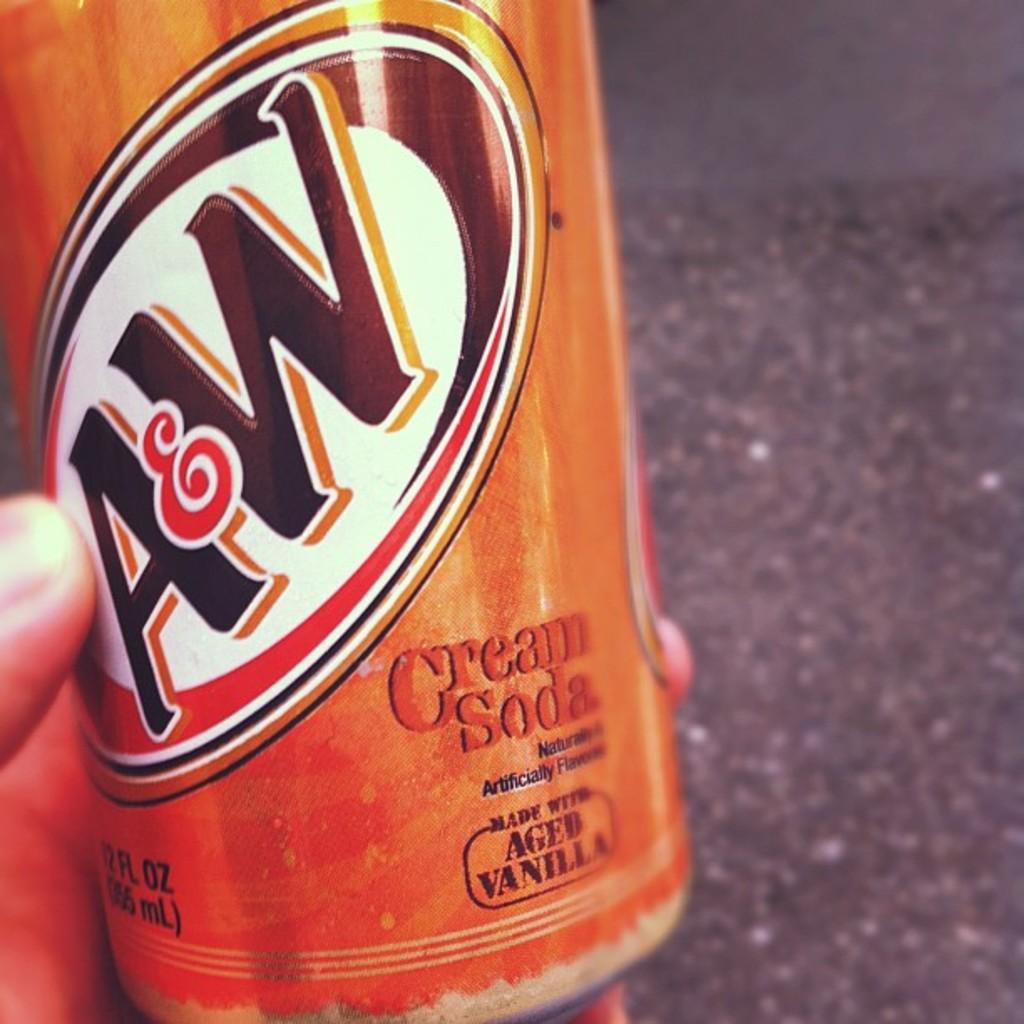<image>
Describe the image concisely. A tin can of A and W branded cream soda with an orange tint. 